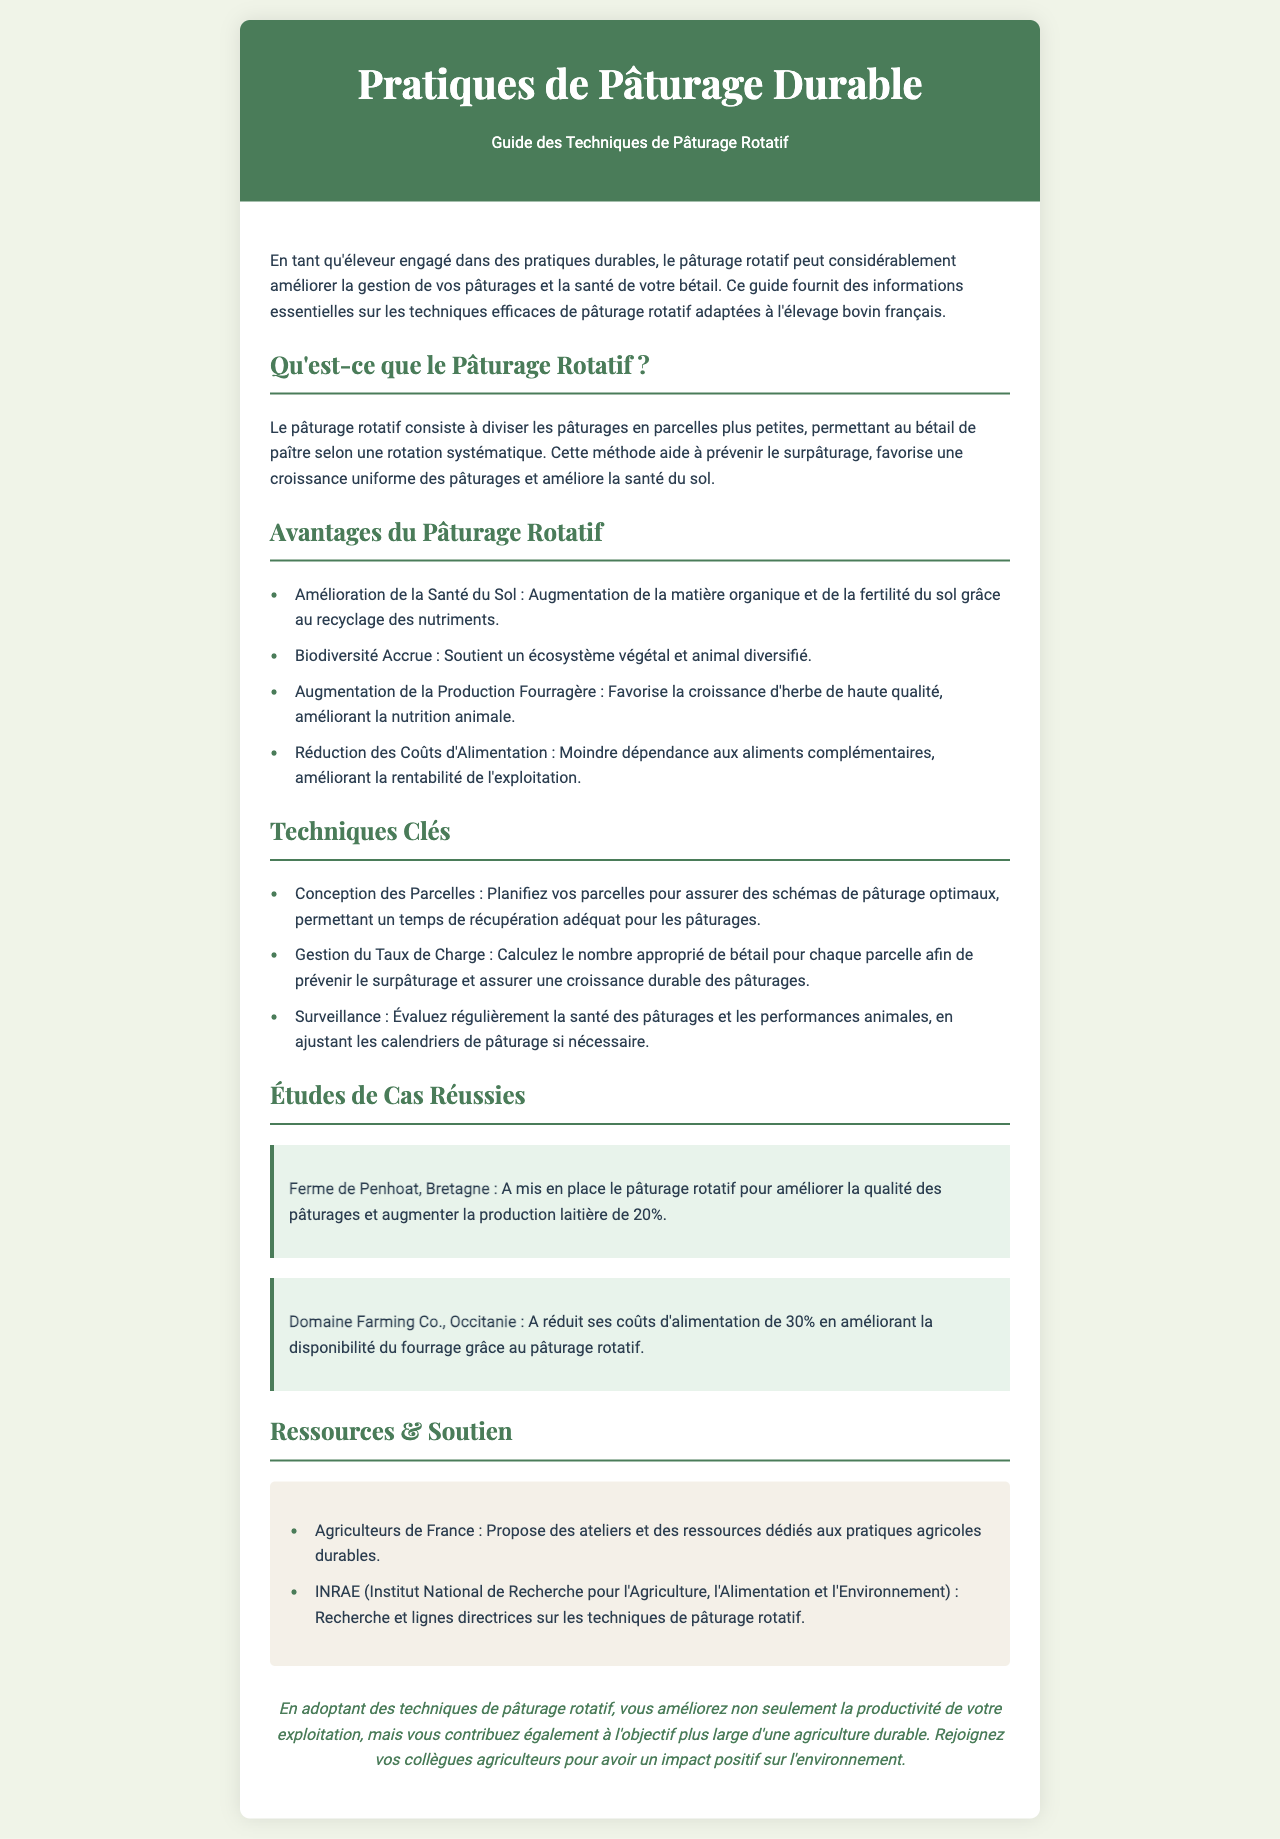Qu'est-ce que le pâturage rotatif ? Le pâturage rotatif consiste à diviser les pâturages en parcelles plus petites, permettant au bétail de paître selon une rotation systématique.
Answer: Diviser les pâturages Quels sont les avantages du pâturage rotatif ? Une des listes dans le document énumère les avantages qui incluent l'amélioration de la santé du sol, la biodiversité accrue, l'augmentation de la production fourragère, et la réduction des coûts d'alimentation.
Answer: Amélioration de la santé du sol Quel pourcentage de production laitière a augmenté à la Ferme de Penhoat ? Le document indique que la production laitière a augmenté de 20% grâce à l'utilisation du pâturage rotatif.
Answer: 20% Quel est un aspect clé de la gestion du pâturage mentionné dans le document ? Le document présente les techniques clés, parmi lesquelles il y a la gestion du taux de charge pour prévenir le surpâturage.
Answer: Gestion du taux de charge Quel organisme fournit des recherches sur les techniques de pâturage rotatif ? Le document mentionne l'INRAE (Institut National de Recherche pour l'Agriculture, l'Alimentation et l'Environnement) comme source de recherches et de lignes directrices.
Answer: INRAE Combien de pourcentage les coûts d'alimentation ont été réduits au Domaine Farming Co. ? Selon le document, le Domaine Farming Co. a réduit ses coûts d'alimentation de 30%.
Answer: 30% 